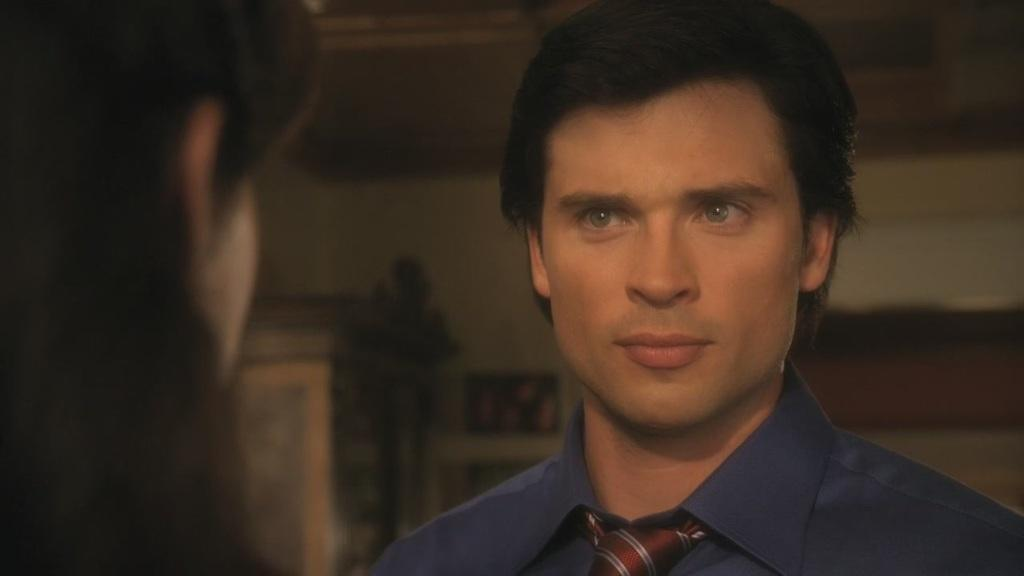How many people are in the image? There are two persons in the image. Can you describe the clothing of one of the men? One man is wearing a blue shirt and a tie. What can be seen in the background of the image? There is a cupboard and photo frames on the wall in the background of the image. What type of locket is the man wearing around his neck in the image? There is no locket visible around the man's neck in the image. Can you tell me the color of the quartz on the table in the image? There is no quartz present in the image. 